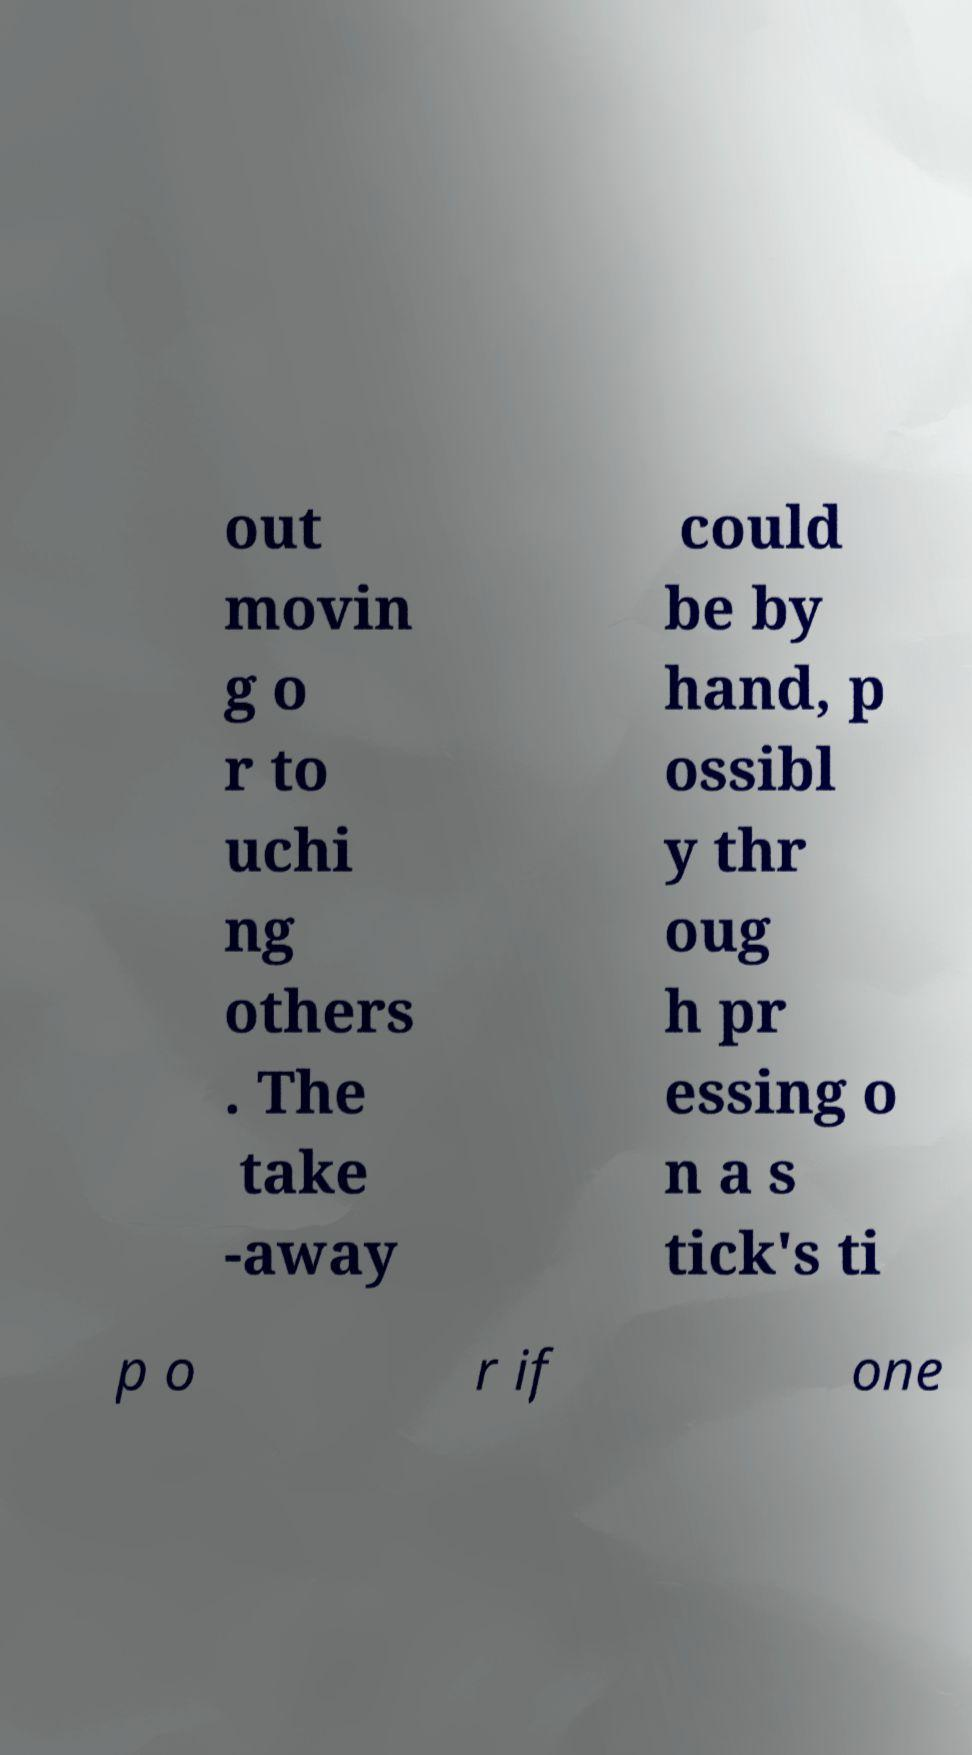I need the written content from this picture converted into text. Can you do that? out movin g o r to uchi ng others . The take -away could be by hand, p ossibl y thr oug h pr essing o n a s tick's ti p o r if one 